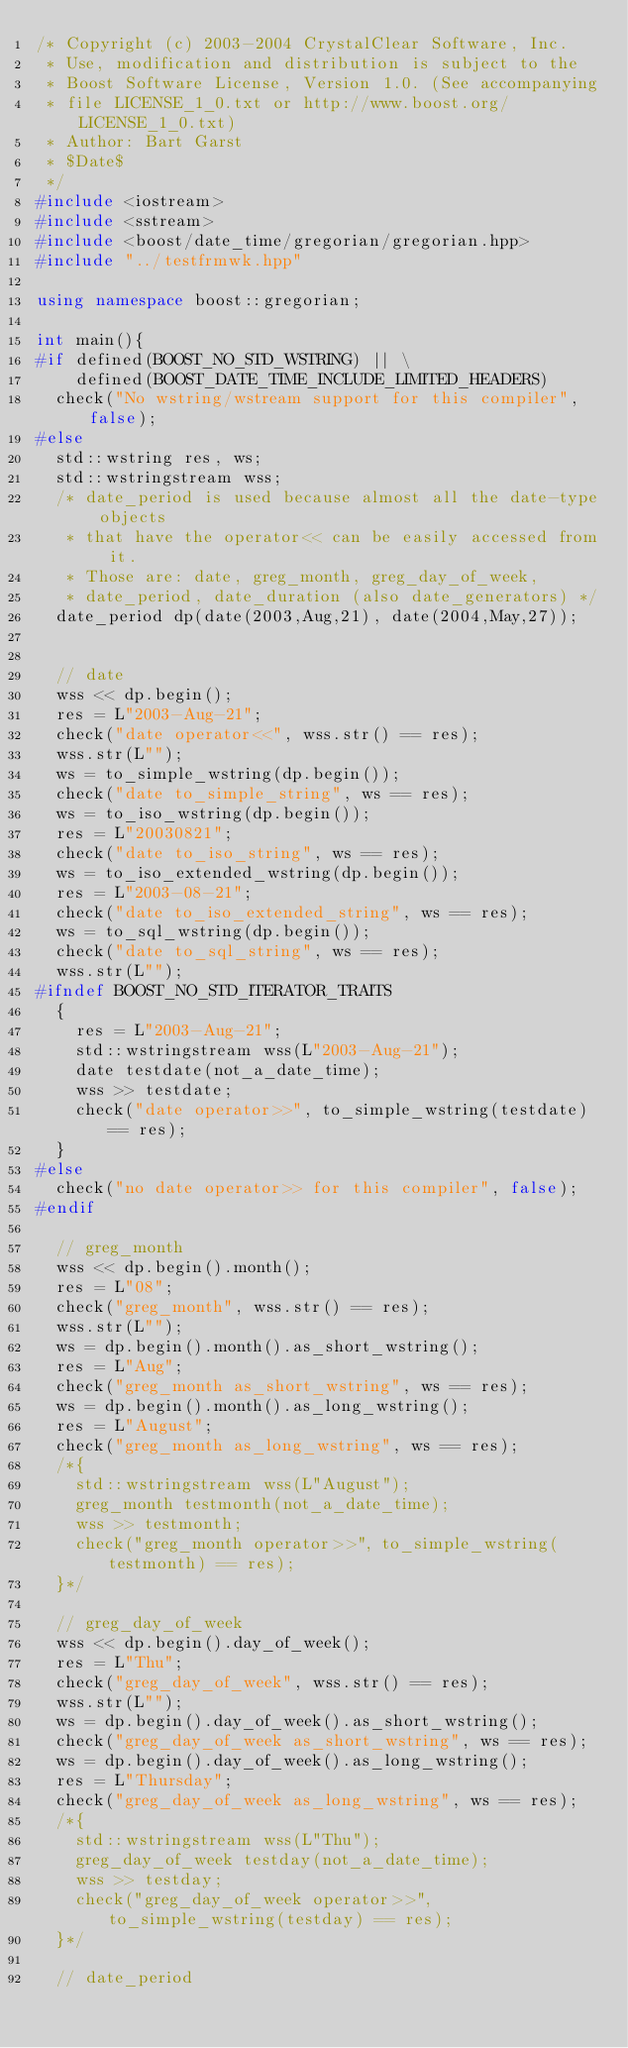Convert code to text. <code><loc_0><loc_0><loc_500><loc_500><_C++_>/* Copyright (c) 2003-2004 CrystalClear Software, Inc.
 * Use, modification and distribution is subject to the
 * Boost Software License, Version 1.0. (See accompanying
 * file LICENSE_1_0.txt or http://www.boost.org/LICENSE_1_0.txt)
 * Author: Bart Garst
 * $Date$
 */
#include <iostream>
#include <sstream>
#include <boost/date_time/gregorian/gregorian.hpp>
#include "../testfrmwk.hpp"

using namespace boost::gregorian;

int main(){
#if defined(BOOST_NO_STD_WSTRING) || \
    defined(BOOST_DATE_TIME_INCLUDE_LIMITED_HEADERS)
  check("No wstring/wstream support for this compiler", false);
#else
  std::wstring res, ws;
  std::wstringstream wss;
  /* date_period is used because almost all the date-type objects 
   * that have the operator<< can be easily accessed from it.
   * Those are: date, greg_month, greg_day_of_week,
   * date_period, date_duration (also date_generators) */
  date_period dp(date(2003,Aug,21), date(2004,May,27));
 
  
  // date
  wss << dp.begin();
  res = L"2003-Aug-21";
  check("date operator<<", wss.str() == res);
  wss.str(L"");
  ws = to_simple_wstring(dp.begin());
  check("date to_simple_string", ws == res);
  ws = to_iso_wstring(dp.begin());
  res = L"20030821";
  check("date to_iso_string", ws == res);
  ws = to_iso_extended_wstring(dp.begin());
  res = L"2003-08-21";
  check("date to_iso_extended_string", ws == res);
  ws = to_sql_wstring(dp.begin());
  check("date to_sql_string", ws == res);
  wss.str(L"");
#ifndef BOOST_NO_STD_ITERATOR_TRAITS
  { 
    res = L"2003-Aug-21";
    std::wstringstream wss(L"2003-Aug-21");
    date testdate(not_a_date_time);
    wss >> testdate;
    check("date operator>>", to_simple_wstring(testdate) == res);
  }
#else
  check("no date operator>> for this compiler", false);
#endif
  
  // greg_month
  wss << dp.begin().month();
  res = L"08";
  check("greg_month", wss.str() == res);
  wss.str(L"");
  ws = dp.begin().month().as_short_wstring();
  res = L"Aug";
  check("greg_month as_short_wstring", ws == res);
  ws = dp.begin().month().as_long_wstring();
  res = L"August";
  check("greg_month as_long_wstring", ws == res);
  /*{ 
    std::wstringstream wss(L"August");
    greg_month testmonth(not_a_date_time);
    wss >> testmonth;
    check("greg_month operator>>", to_simple_wstring(testmonth) == res);
  }*/
  
  // greg_day_of_week
  wss << dp.begin().day_of_week();
  res = L"Thu";
  check("greg_day_of_week", wss.str() == res);
  wss.str(L"");
  ws = dp.begin().day_of_week().as_short_wstring();
  check("greg_day_of_week as_short_wstring", ws == res);
  ws = dp.begin().day_of_week().as_long_wstring();
  res = L"Thursday";
  check("greg_day_of_week as_long_wstring", ws == res);
  /*{ 
    std::wstringstream wss(L"Thu");
    greg_day_of_week testday(not_a_date_time);
    wss >> testday;
    check("greg_day_of_week operator>>", to_simple_wstring(testday) == res);
  }*/
  
  // date_period</code> 